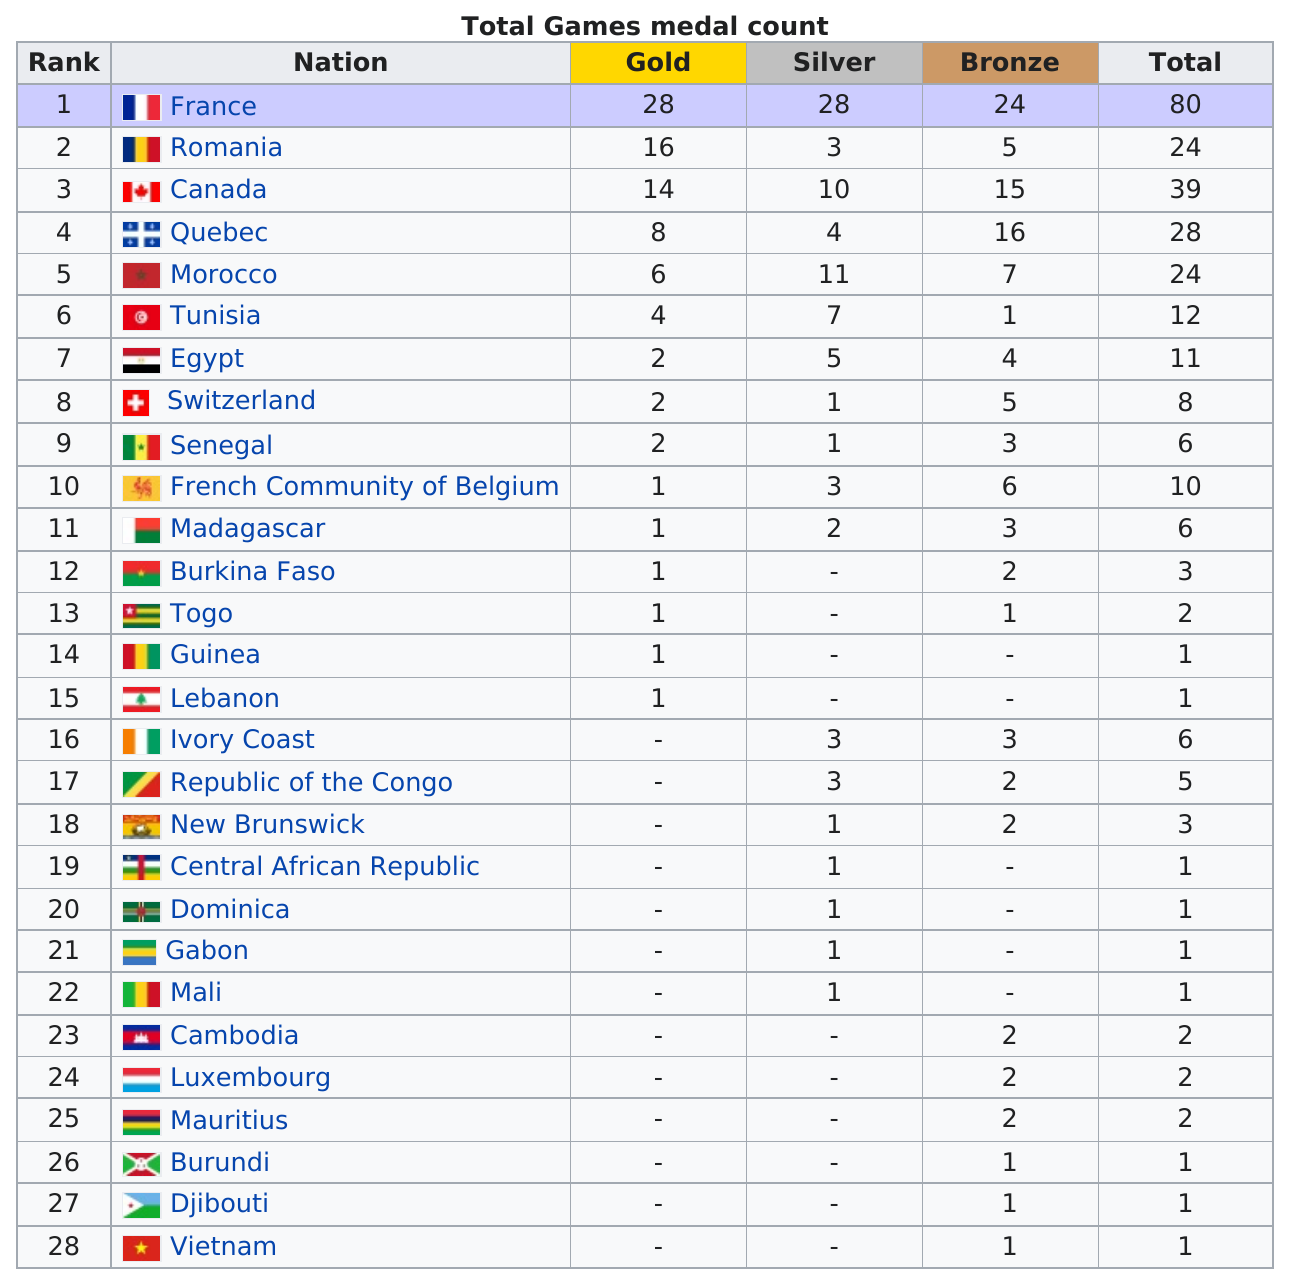Point out several critical features in this image. There are 18 counties that have at least one silver medal. In a comparison of France's and Egypt's silver medals, France's medal is different from Egypt's medal in a specific way. Egypt won more medals than Ivory Coast by a margin of 5. Canada did not have more silver medals than Morocco. Out of the 9 nations that won only one medal, 7 of them won a silver medal, while the remaining 2 won a bronze medal. 